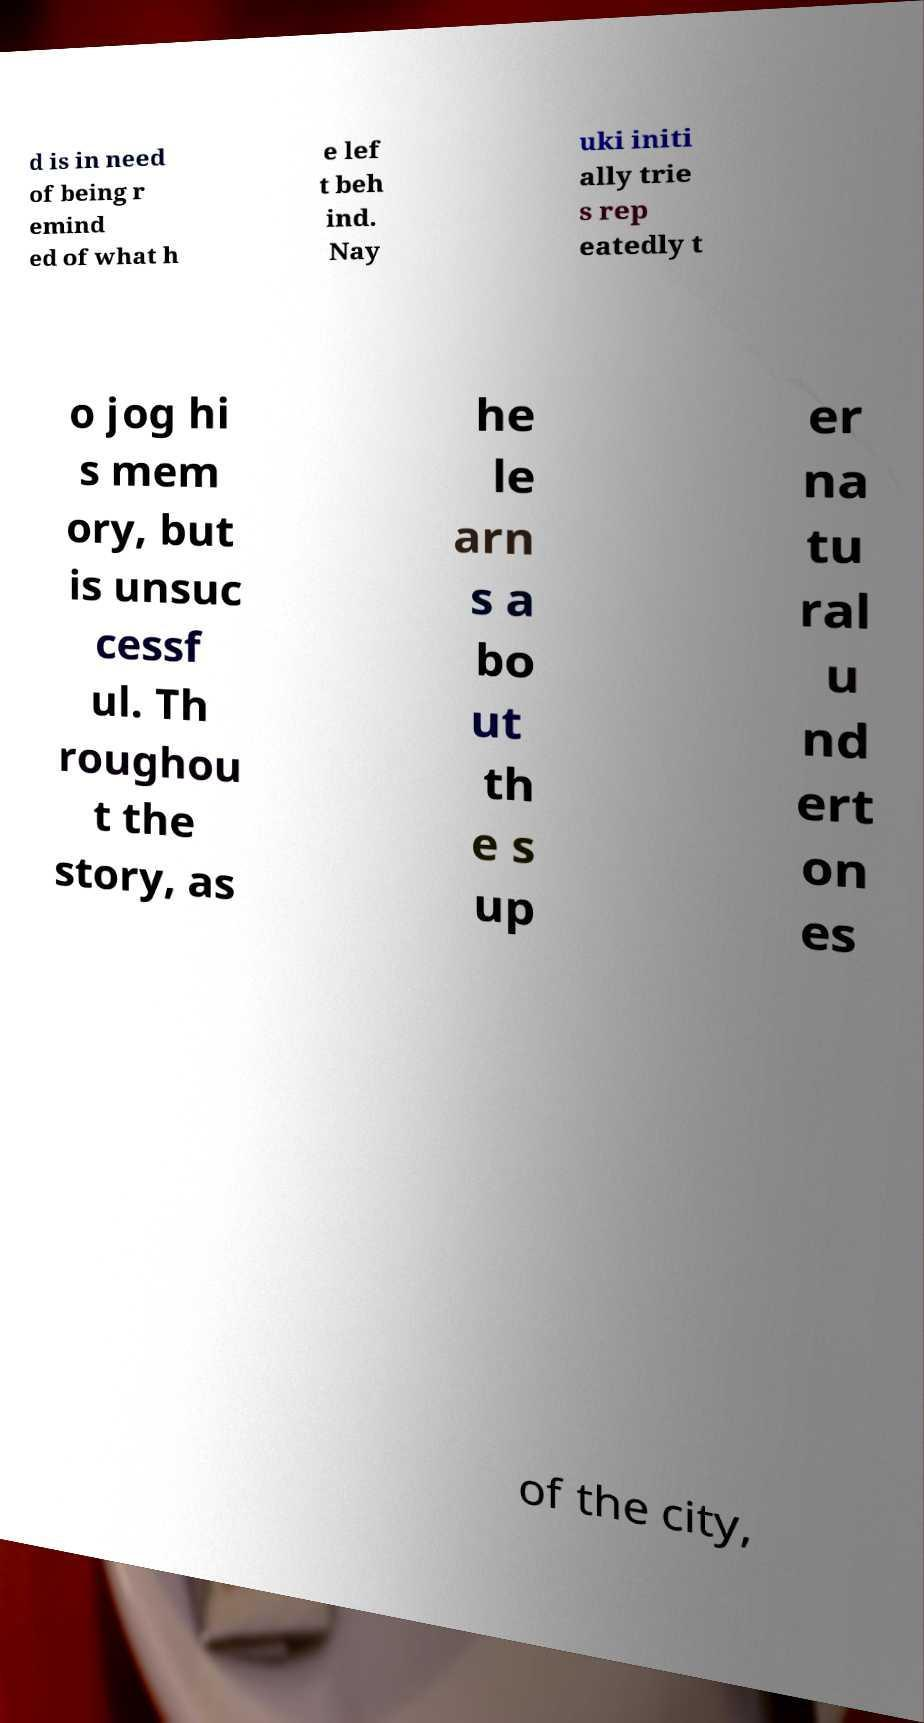What messages or text are displayed in this image? I need them in a readable, typed format. d is in need of being r emind ed of what h e lef t beh ind. Nay uki initi ally trie s rep eatedly t o jog hi s mem ory, but is unsuc cessf ul. Th roughou t the story, as he le arn s a bo ut th e s up er na tu ral u nd ert on es of the city, 